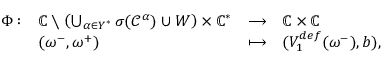Convert formula to latex. <formula><loc_0><loc_0><loc_500><loc_500>\begin{array} { r } { \begin{array} { l l l l } { \Phi \colon } & { \mathbb { C } \ \left ( \bigcup _ { \alpha \in Y ^ { * } } \sigma ( \mathcal { C } ^ { \alpha } ) \cup W \right ) \times \mathbb { C } ^ { * } } & { \longrightarrow } & { \mathbb { C } \times \mathbb { C } } \\ & { ( \omega ^ { - } , \omega ^ { + } ) } & { \longmapsto } & { ( V _ { 1 } ^ { d e f } ( \omega ^ { - } ) , b ) , } \end{array} } \end{array}</formula> 